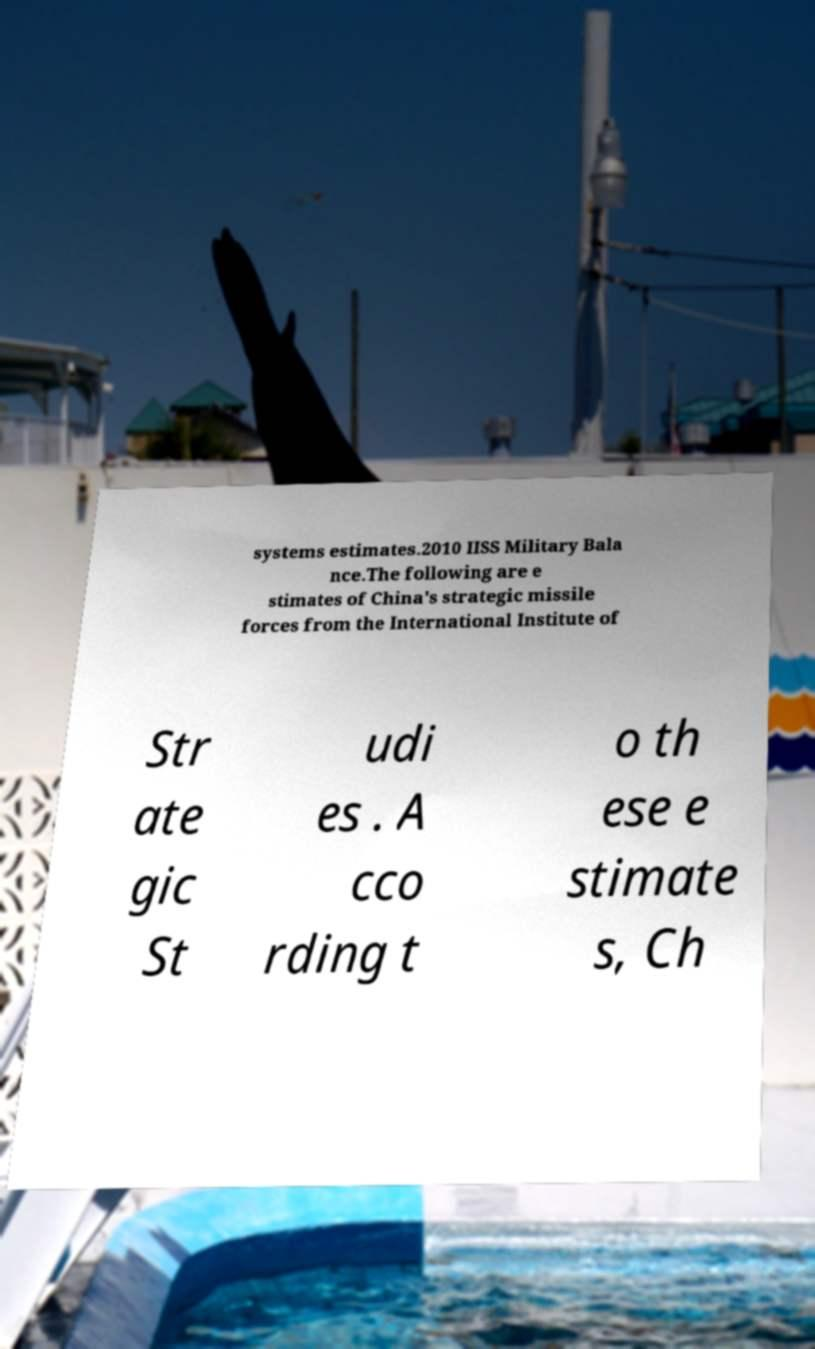Can you read and provide the text displayed in the image?This photo seems to have some interesting text. Can you extract and type it out for me? systems estimates.2010 IISS Military Bala nce.The following are e stimates of China's strategic missile forces from the International Institute of Str ate gic St udi es . A cco rding t o th ese e stimate s, Ch 